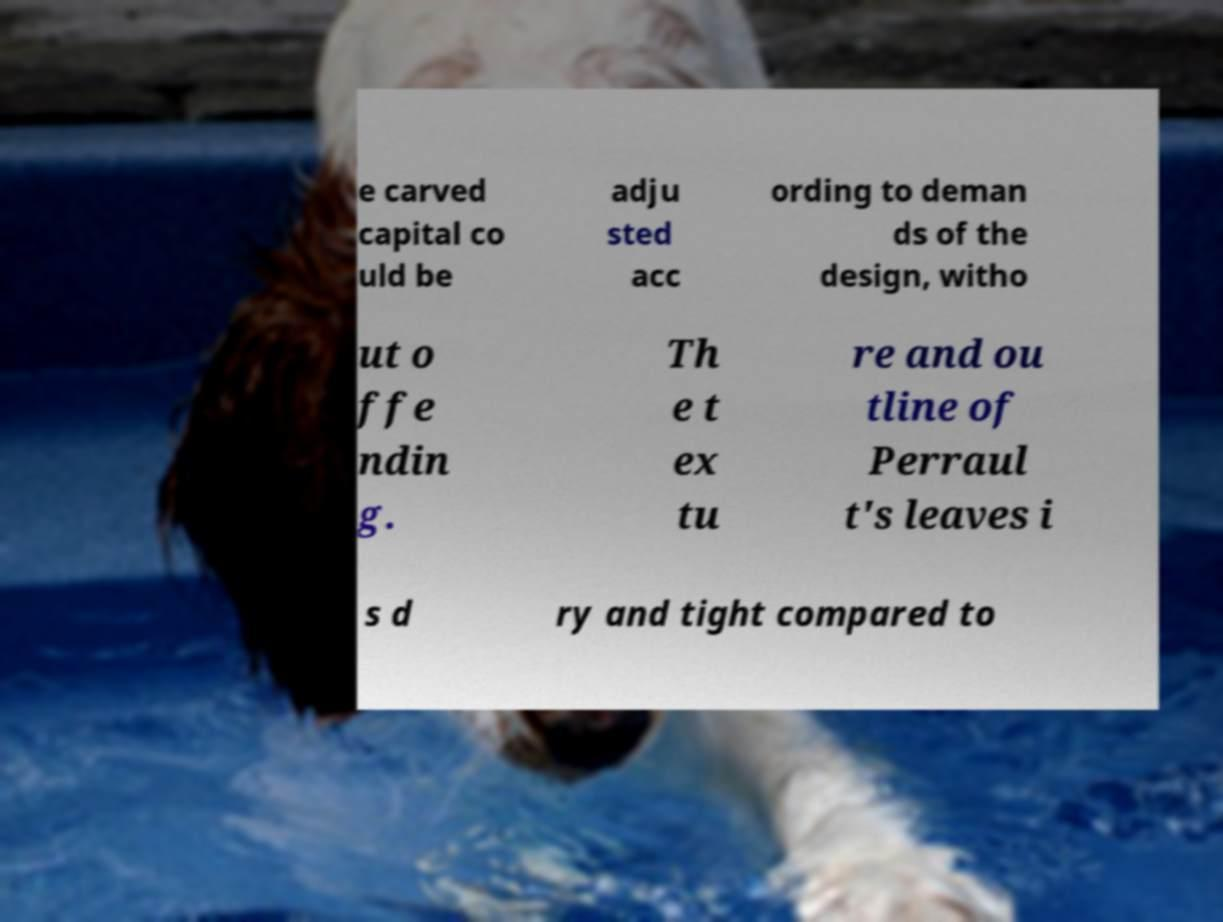Please identify and transcribe the text found in this image. e carved capital co uld be adju sted acc ording to deman ds of the design, witho ut o ffe ndin g. Th e t ex tu re and ou tline of Perraul t's leaves i s d ry and tight compared to 